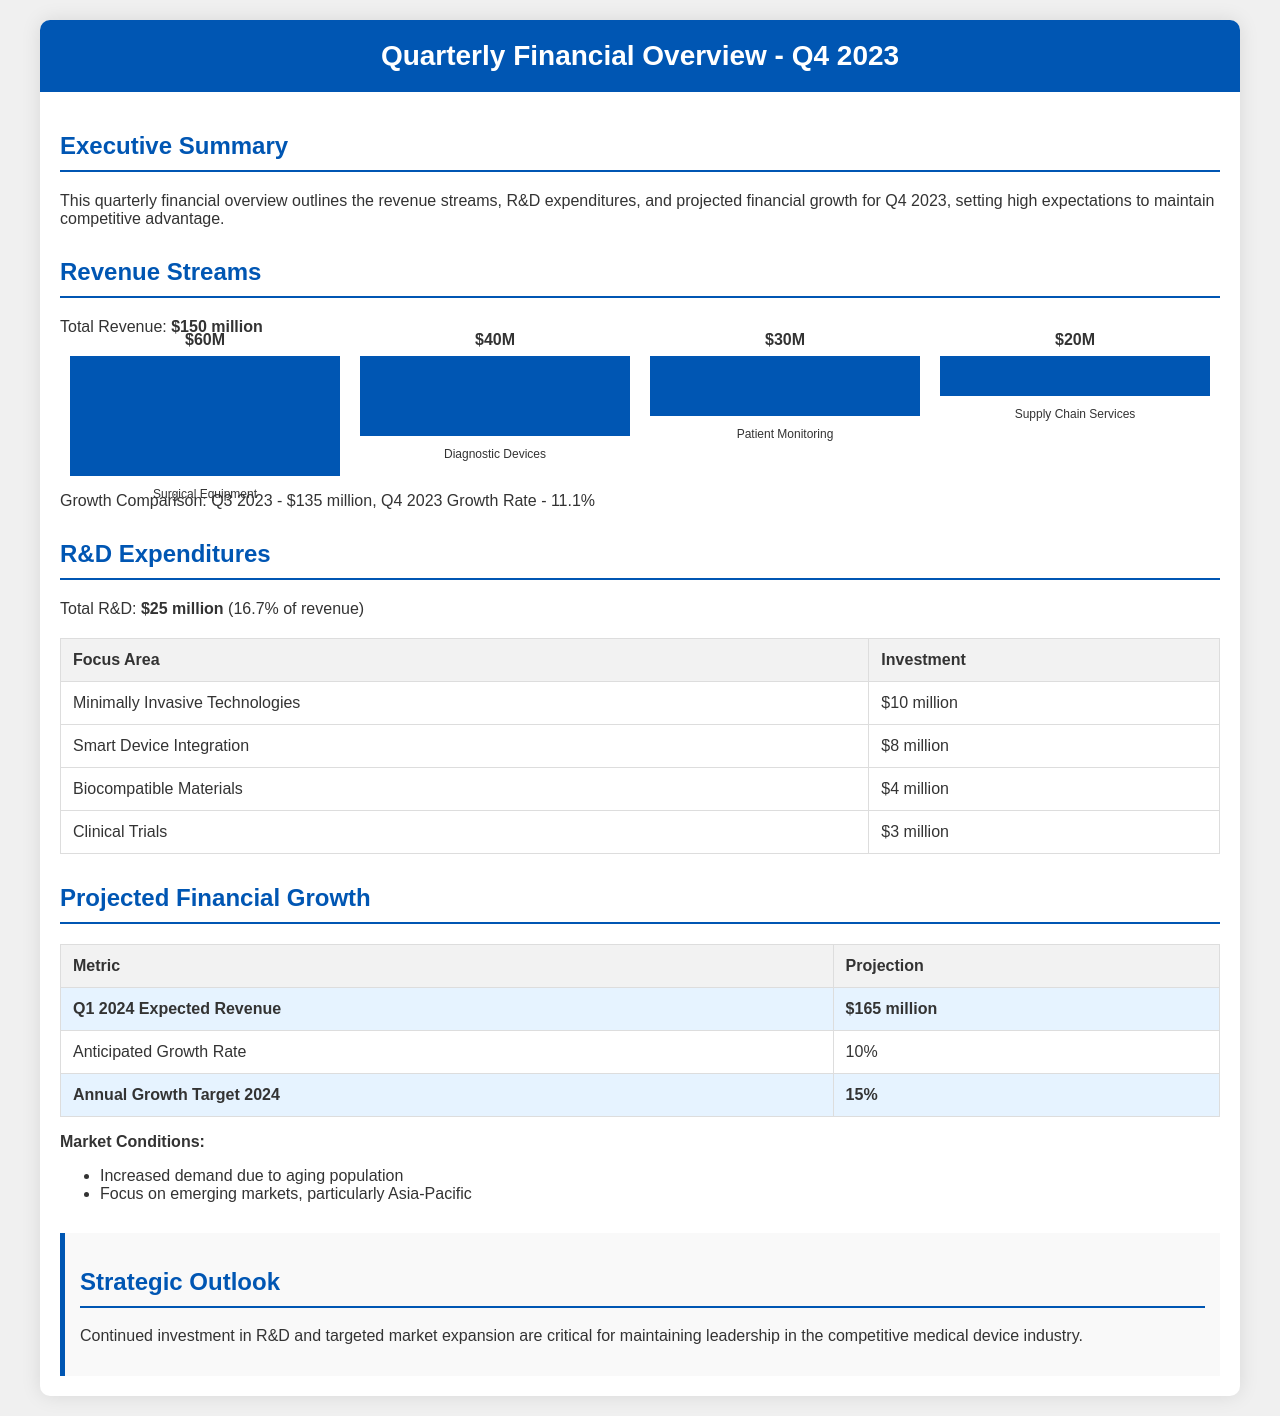What is the total revenue for Q4 2023? The total revenue is stated as $150 million in the document.
Answer: $150 million What is the growth rate from Q3 2023 to Q4 2023? The growth rate from Q3 2023 to Q4 2023 is provided as 11.1%.
Answer: 11.1% What is the total R&D expenditure? The total R&D expenditure is mentioned as $25 million in the document.
Answer: $25 million What is the investment in Smart Device Integration? The investment in Smart Device Integration is detailed as $8 million.
Answer: $8 million What is the expected revenue for Q1 2024? The projected expected revenue for Q1 2024 is specified as $165 million in the document.
Answer: $165 million How much is allocated to Clinical Trials? The allocation for Clinical Trials is documented as $3 million.
Answer: $3 million What percentage of revenue is spent on R&D? The percentage of revenue spent on R&D is calculated as 16.7%.
Answer: 16.7% What is the annual growth target for 2024? The annual growth target for 2024 is outlined as 15%.
Answer: 15% What market condition is driving demand? The increased demand is attributed to the aging population.
Answer: Aging population 